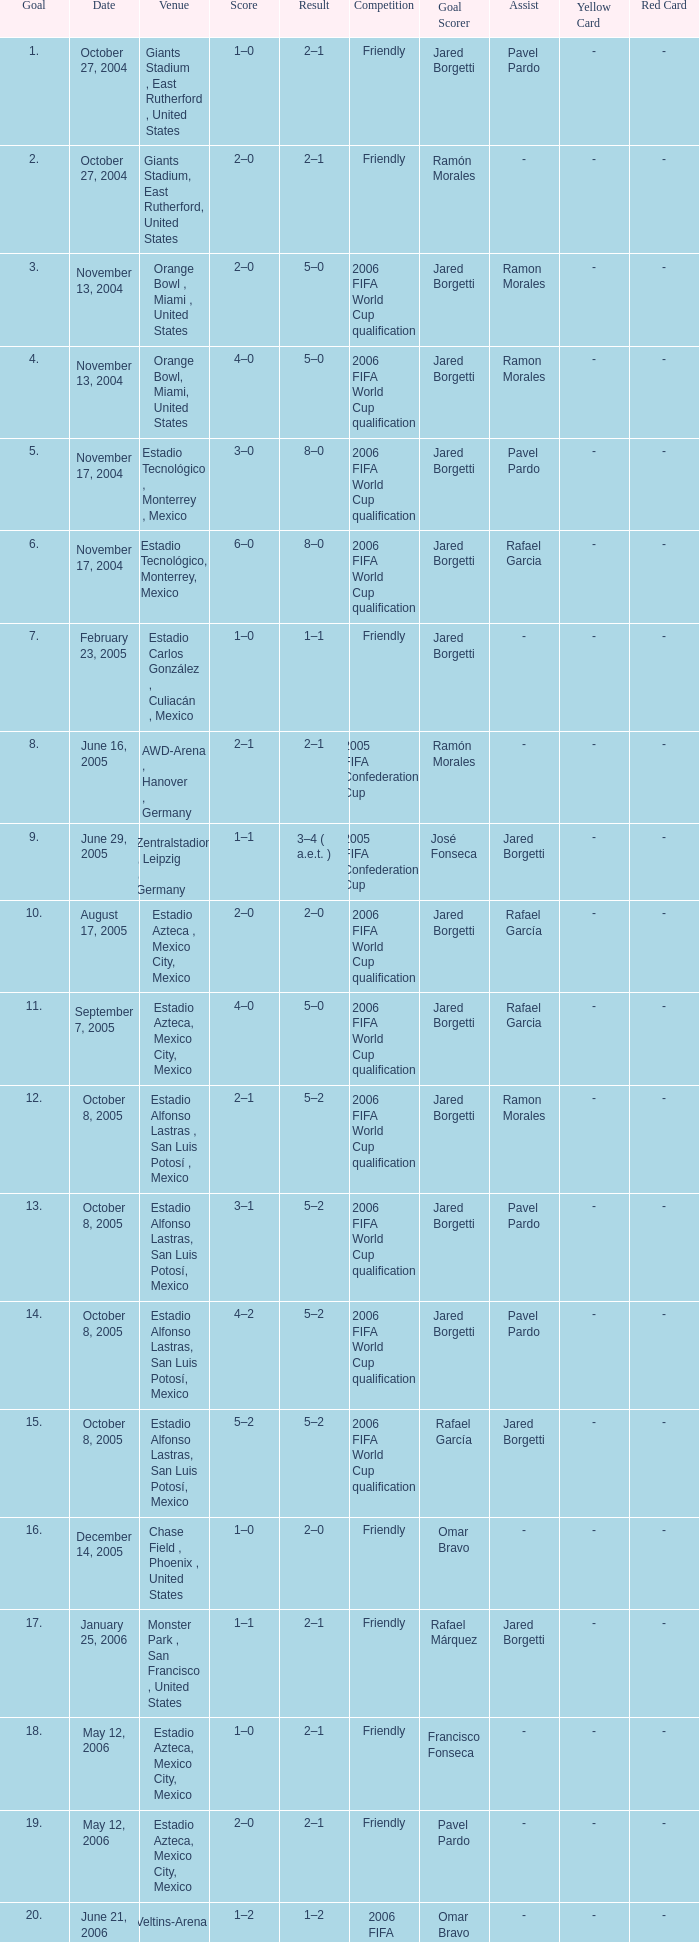Which Result has a Score of 1–0, and a Goal of 16? 2–0. 